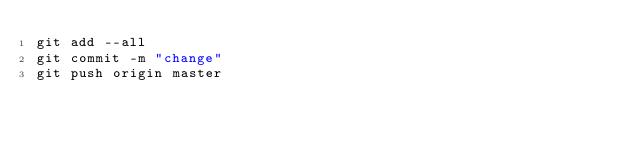<code> <loc_0><loc_0><loc_500><loc_500><_Bash_>git add --all
git commit -m "change"
git push origin master
</code> 